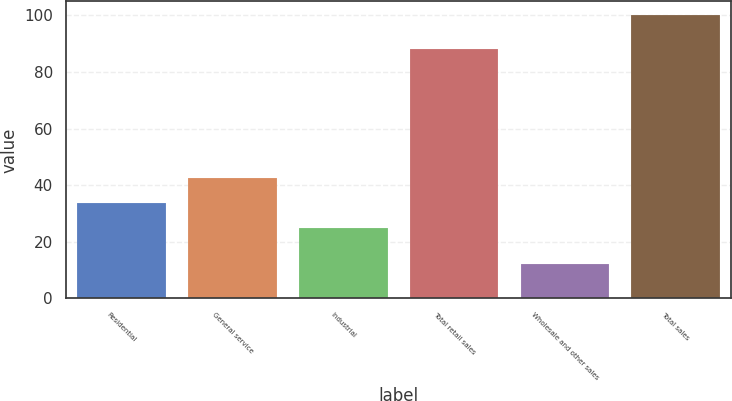<chart> <loc_0><loc_0><loc_500><loc_500><bar_chart><fcel>Residential<fcel>General service<fcel>Industrial<fcel>Total retail sales<fcel>Wholesale and other sales<fcel>Total sales<nl><fcel>33.8<fcel>42.6<fcel>25<fcel>88<fcel>12<fcel>100<nl></chart> 